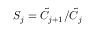<formula> <loc_0><loc_0><loc_500><loc_500>S _ { j } = \tilde { C } _ { j + 1 } / \tilde { C } _ { j }</formula> 